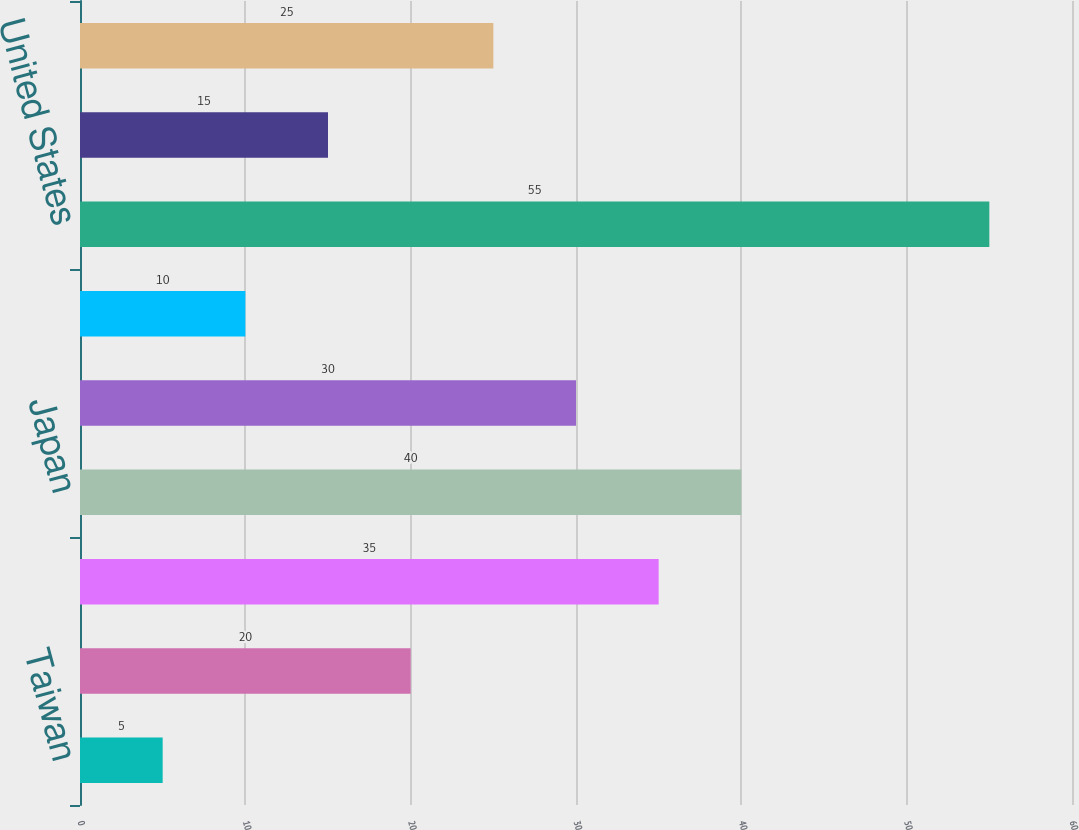<chart> <loc_0><loc_0><loc_500><loc_500><bar_chart><fcel>Taiwan<fcel>China<fcel>Korea<fcel>Japan<fcel>Southeast Asia<fcel>Asia Pacific<fcel>United States<fcel>Europe<fcel>Total<nl><fcel>5<fcel>20<fcel>35<fcel>40<fcel>30<fcel>10<fcel>55<fcel>15<fcel>25<nl></chart> 